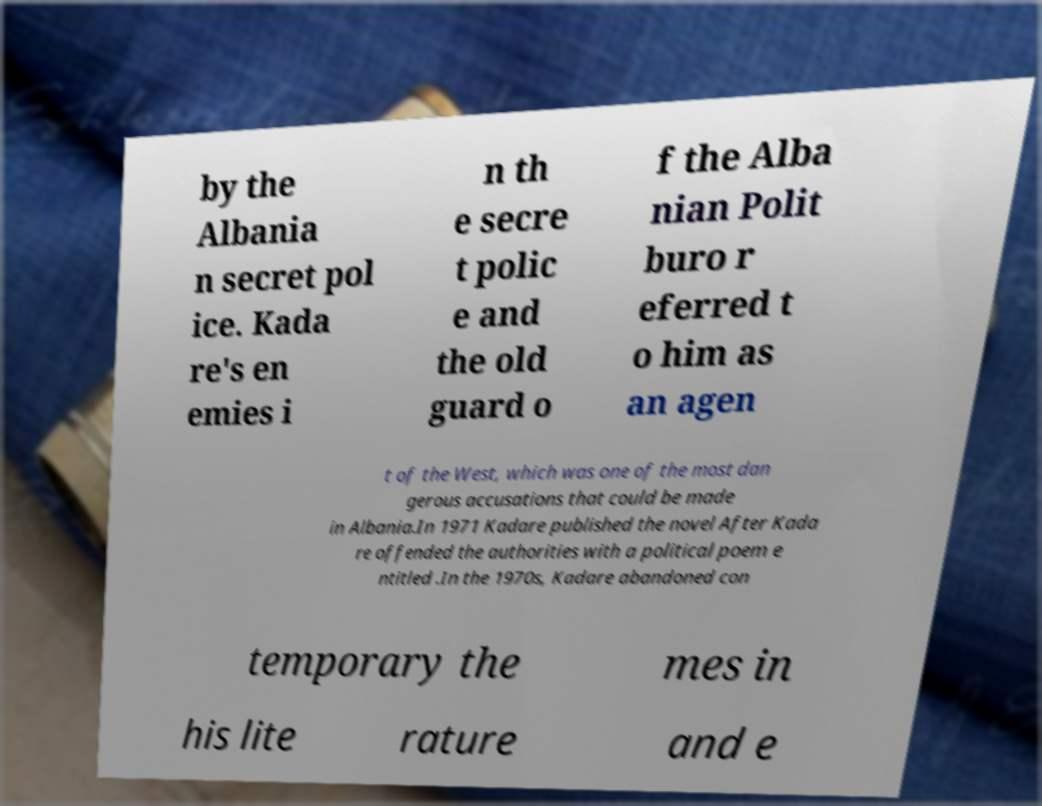Can you read and provide the text displayed in the image?This photo seems to have some interesting text. Can you extract and type it out for me? by the Albania n secret pol ice. Kada re's en emies i n th e secre t polic e and the old guard o f the Alba nian Polit buro r eferred t o him as an agen t of the West, which was one of the most dan gerous accusations that could be made in Albania.In 1971 Kadare published the novel After Kada re offended the authorities with a political poem e ntitled .In the 1970s, Kadare abandoned con temporary the mes in his lite rature and e 